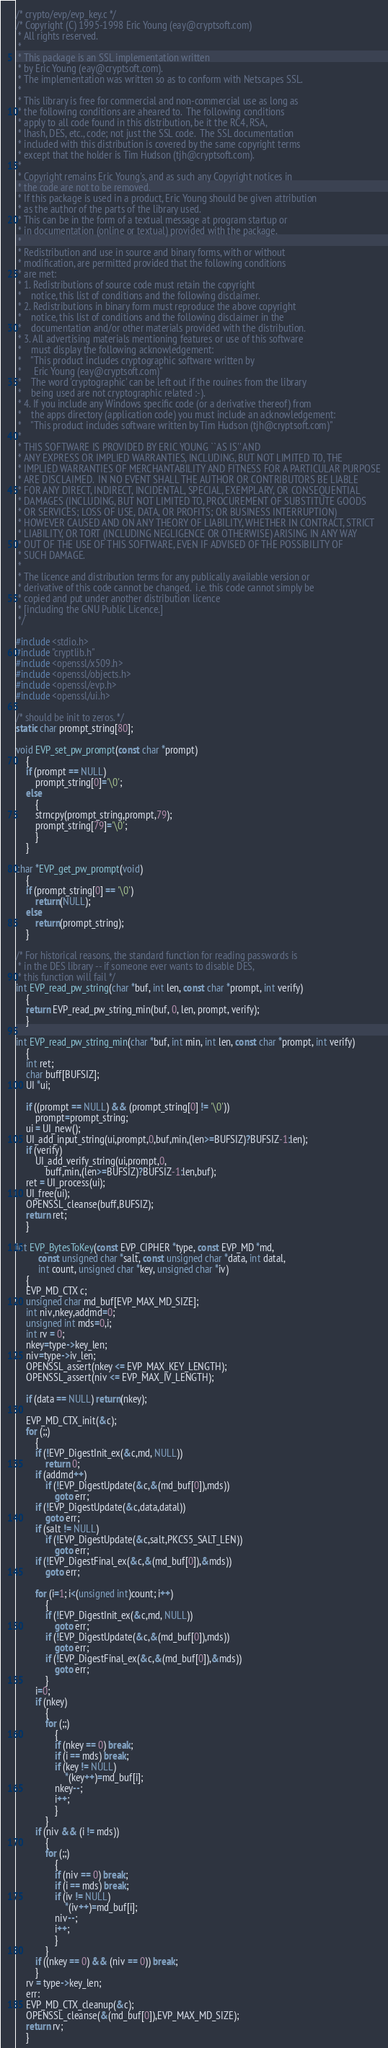<code> <loc_0><loc_0><loc_500><loc_500><_C_>/* crypto/evp/evp_key.c */
/* Copyright (C) 1995-1998 Eric Young (eay@cryptsoft.com)
 * All rights reserved.
 *
 * This package is an SSL implementation written
 * by Eric Young (eay@cryptsoft.com).
 * The implementation was written so as to conform with Netscapes SSL.
 * 
 * This library is free for commercial and non-commercial use as long as
 * the following conditions are aheared to.  The following conditions
 * apply to all code found in this distribution, be it the RC4, RSA,
 * lhash, DES, etc., code; not just the SSL code.  The SSL documentation
 * included with this distribution is covered by the same copyright terms
 * except that the holder is Tim Hudson (tjh@cryptsoft.com).
 * 
 * Copyright remains Eric Young's, and as such any Copyright notices in
 * the code are not to be removed.
 * If this package is used in a product, Eric Young should be given attribution
 * as the author of the parts of the library used.
 * This can be in the form of a textual message at program startup or
 * in documentation (online or textual) provided with the package.
 * 
 * Redistribution and use in source and binary forms, with or without
 * modification, are permitted provided that the following conditions
 * are met:
 * 1. Redistributions of source code must retain the copyright
 *    notice, this list of conditions and the following disclaimer.
 * 2. Redistributions in binary form must reproduce the above copyright
 *    notice, this list of conditions and the following disclaimer in the
 *    documentation and/or other materials provided with the distribution.
 * 3. All advertising materials mentioning features or use of this software
 *    must display the following acknowledgement:
 *    "This product includes cryptographic software written by
 *     Eric Young (eay@cryptsoft.com)"
 *    The word 'cryptographic' can be left out if the rouines from the library
 *    being used are not cryptographic related :-).
 * 4. If you include any Windows specific code (or a derivative thereof) from 
 *    the apps directory (application code) you must include an acknowledgement:
 *    "This product includes software written by Tim Hudson (tjh@cryptsoft.com)"
 * 
 * THIS SOFTWARE IS PROVIDED BY ERIC YOUNG ``AS IS'' AND
 * ANY EXPRESS OR IMPLIED WARRANTIES, INCLUDING, BUT NOT LIMITED TO, THE
 * IMPLIED WARRANTIES OF MERCHANTABILITY AND FITNESS FOR A PARTICULAR PURPOSE
 * ARE DISCLAIMED.  IN NO EVENT SHALL THE AUTHOR OR CONTRIBUTORS BE LIABLE
 * FOR ANY DIRECT, INDIRECT, INCIDENTAL, SPECIAL, EXEMPLARY, OR CONSEQUENTIAL
 * DAMAGES (INCLUDING, BUT NOT LIMITED TO, PROCUREMENT OF SUBSTITUTE GOODS
 * OR SERVICES; LOSS OF USE, DATA, OR PROFITS; OR BUSINESS INTERRUPTION)
 * HOWEVER CAUSED AND ON ANY THEORY OF LIABILITY, WHETHER IN CONTRACT, STRICT
 * LIABILITY, OR TORT (INCLUDING NEGLIGENCE OR OTHERWISE) ARISING IN ANY WAY
 * OUT OF THE USE OF THIS SOFTWARE, EVEN IF ADVISED OF THE POSSIBILITY OF
 * SUCH DAMAGE.
 * 
 * The licence and distribution terms for any publically available version or
 * derivative of this code cannot be changed.  i.e. this code cannot simply be
 * copied and put under another distribution licence
 * [including the GNU Public Licence.]
 */

#include <stdio.h>
#include "cryptlib.h"
#include <openssl/x509.h>
#include <openssl/objects.h>
#include <openssl/evp.h>
#include <openssl/ui.h>

/* should be init to zeros. */
static char prompt_string[80];

void EVP_set_pw_prompt(const char *prompt)
	{
	if (prompt == NULL)
		prompt_string[0]='\0';
	else
		{
		strncpy(prompt_string,prompt,79);
		prompt_string[79]='\0';
		}
	}

char *EVP_get_pw_prompt(void)
	{
	if (prompt_string[0] == '\0')
		return(NULL);
	else
		return(prompt_string);
	}

/* For historical reasons, the standard function for reading passwords is
 * in the DES library -- if someone ever wants to disable DES,
 * this function will fail */
int EVP_read_pw_string(char *buf, int len, const char *prompt, int verify)
	{
	return EVP_read_pw_string_min(buf, 0, len, prompt, verify);
	}

int EVP_read_pw_string_min(char *buf, int min, int len, const char *prompt, int verify)
	{
	int ret;
	char buff[BUFSIZ];
	UI *ui;

	if ((prompt == NULL) && (prompt_string[0] != '\0'))
		prompt=prompt_string;
	ui = UI_new();
	UI_add_input_string(ui,prompt,0,buf,min,(len>=BUFSIZ)?BUFSIZ-1:len);
	if (verify)
		UI_add_verify_string(ui,prompt,0,
			buff,min,(len>=BUFSIZ)?BUFSIZ-1:len,buf);
	ret = UI_process(ui);
	UI_free(ui);
	OPENSSL_cleanse(buff,BUFSIZ);
	return ret;
	}

int EVP_BytesToKey(const EVP_CIPHER *type, const EVP_MD *md, 
	     const unsigned char *salt, const unsigned char *data, int datal,
	     int count, unsigned char *key, unsigned char *iv)
	{
	EVP_MD_CTX c;
	unsigned char md_buf[EVP_MAX_MD_SIZE];
	int niv,nkey,addmd=0;
	unsigned int mds=0,i;
	int rv = 0;
	nkey=type->key_len;
	niv=type->iv_len;
	OPENSSL_assert(nkey <= EVP_MAX_KEY_LENGTH);
	OPENSSL_assert(niv <= EVP_MAX_IV_LENGTH);

	if (data == NULL) return(nkey);

	EVP_MD_CTX_init(&c);
	for (;;)
		{
		if (!EVP_DigestInit_ex(&c,md, NULL))
			return 0;
		if (addmd++)
			if (!EVP_DigestUpdate(&c,&(md_buf[0]),mds))
				goto err;
		if (!EVP_DigestUpdate(&c,data,datal))
			goto err;
		if (salt != NULL)
			if (!EVP_DigestUpdate(&c,salt,PKCS5_SALT_LEN))
				goto err;
		if (!EVP_DigestFinal_ex(&c,&(md_buf[0]),&mds))
			goto err;

		for (i=1; i<(unsigned int)count; i++)
			{
			if (!EVP_DigestInit_ex(&c,md, NULL))
				goto err;
			if (!EVP_DigestUpdate(&c,&(md_buf[0]),mds))
				goto err;
			if (!EVP_DigestFinal_ex(&c,&(md_buf[0]),&mds))
				goto err;
			}
		i=0;
		if (nkey)
			{
			for (;;)
				{
				if (nkey == 0) break;
				if (i == mds) break;
				if (key != NULL)
					*(key++)=md_buf[i];
				nkey--;
				i++;
				}
			}
		if (niv && (i != mds))
			{
			for (;;)
				{
				if (niv == 0) break;
				if (i == mds) break;
				if (iv != NULL)
					*(iv++)=md_buf[i];
				niv--;
				i++;
				}
			}
		if ((nkey == 0) && (niv == 0)) break;
		}
	rv = type->key_len;
	err:
	EVP_MD_CTX_cleanup(&c);
	OPENSSL_cleanse(&(md_buf[0]),EVP_MAX_MD_SIZE);
	return rv;
	}

</code> 